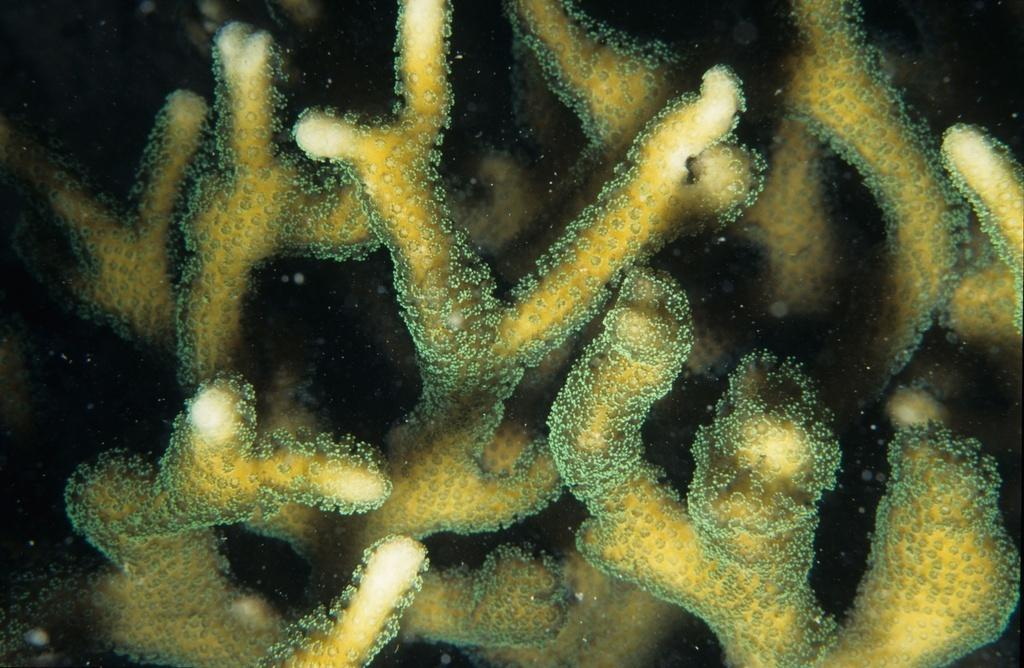What type of underwater environment is depicted in the image? There is a coral reef in the image. What might be found living in or around the coral reef? Various marine life, such as fish and sea creatures, might be found living in or around the coral reef. What is the color and texture of the coral reef in the image? The color and texture of the coral reef in the image can vary depending on the species of coral present. How many legs can be seen on the coral reef in the image? Coral reefs do not have legs; they are made up of colonies of tiny marine invertebrates called polyps. 